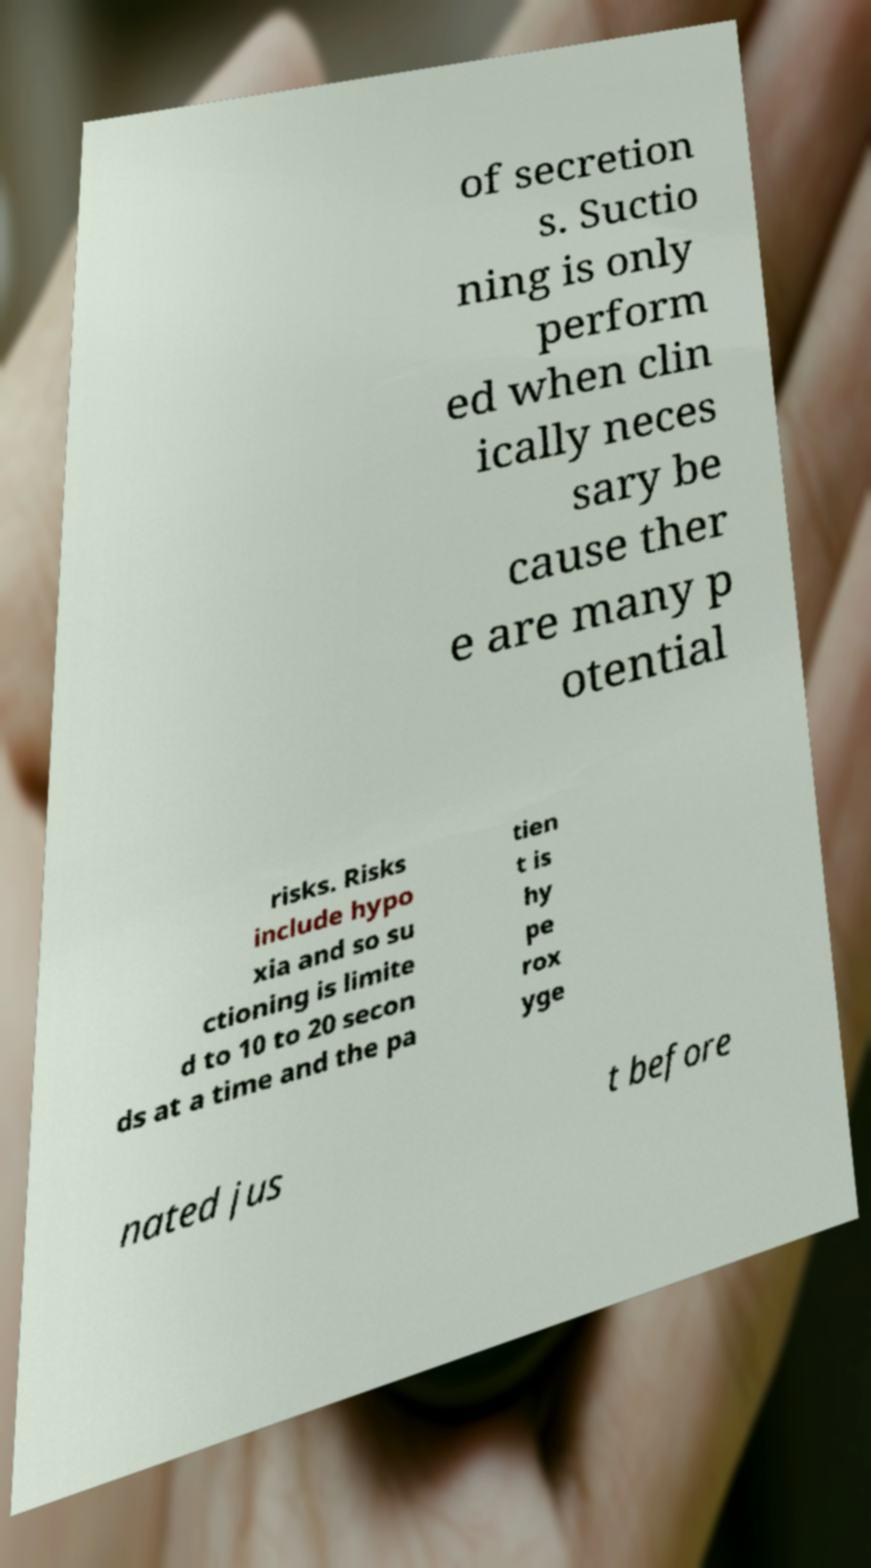Could you assist in decoding the text presented in this image and type it out clearly? of secretion s. Suctio ning is only perform ed when clin ically neces sary be cause ther e are many p otential risks. Risks include hypo xia and so su ctioning is limite d to 10 to 20 secon ds at a time and the pa tien t is hy pe rox yge nated jus t before 